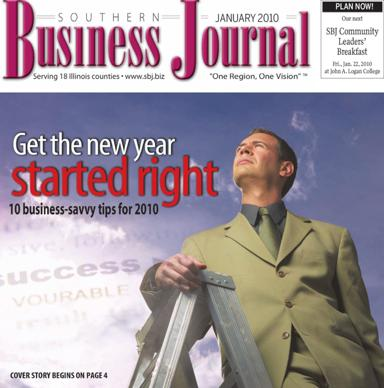What event is being advertised in the image? The image is advertising the SBJ Community Leaders' Breakfast that takes place in January 2010. In which publication can I find the 10 business savvy tips for 2010? You can find the 10 business savvy tips for 2010 in the Southern Business Journal, also called the SBJ. The cover story begins on page 4. 